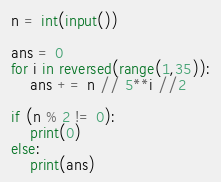<code> <loc_0><loc_0><loc_500><loc_500><_Python_>n = int(input())

ans = 0
for i in reversed(range(1,35)):
    ans += n // 5**i //2

if (n % 2 != 0):
    print(0)
else:
    print(ans)
</code> 